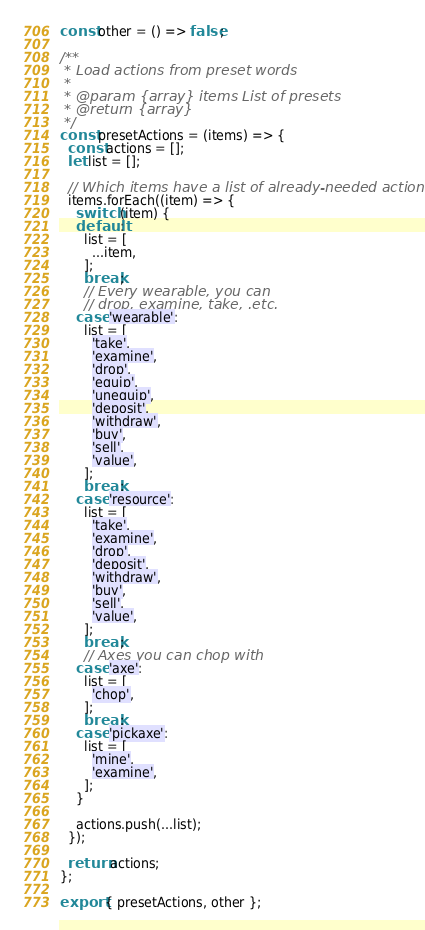<code> <loc_0><loc_0><loc_500><loc_500><_JavaScript_>const other = () => false;

/**
 * Load actions from preset words
 *
 * @param {array} items List of presets
 * @return {array}
 */
const presetActions = (items) => {
  const actions = [];
  let list = [];

  // Which items have a list of already-needed actions?
  items.forEach((item) => {
    switch (item) {
    default:
      list = [
        ...item,
      ];
      break;
      // Every wearable, you can
      // drop, examine, take, .etc.
    case 'wearable':
      list = [
        'take',
        'examine',
        'drop',
        'equip',
        'unequip',
        'deposit',
        'withdraw',
        'buy',
        'sell',
        'value',
      ];
      break;
    case 'resource':
      list = [
        'take',
        'examine',
        'drop',
        'deposit',
        'withdraw',
        'buy',
        'sell',
        'value',
      ];
      break;
      // Axes you can chop with
    case 'axe':
      list = [
        'chop',
      ];
      break;
    case 'pickaxe':
      list = [
        'mine',
        'examine',
      ];
    }

    actions.push(...list);
  });

  return actions;
};

export { presetActions, other };
</code> 